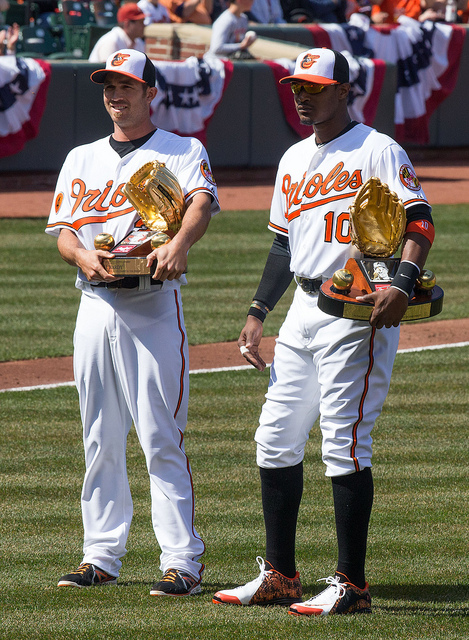<image>Where is the pitcher? I'm unsure where the pitcher is. It can be on the field, on the right, or there may not be one present. Where is the pitcher? It is ambiguous where the pitcher is. It can be seen on the right, left, infield, standing, or on the pitchers mound. 